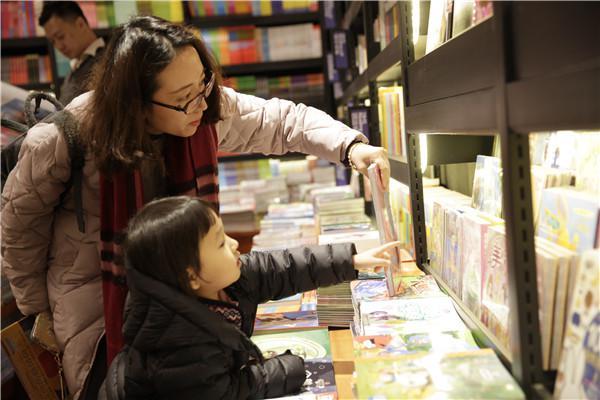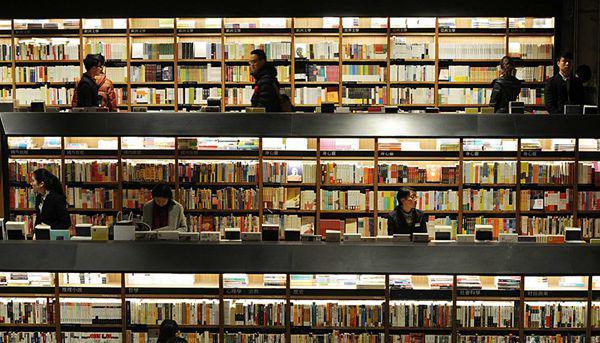The first image is the image on the left, the second image is the image on the right. Considering the images on both sides, is "There are people sitting." valid? Answer yes or no. No. The first image is the image on the left, the second image is the image on the right. For the images displayed, is the sentence "Each image shows the outside window of the business." factually correct? Answer yes or no. No. 